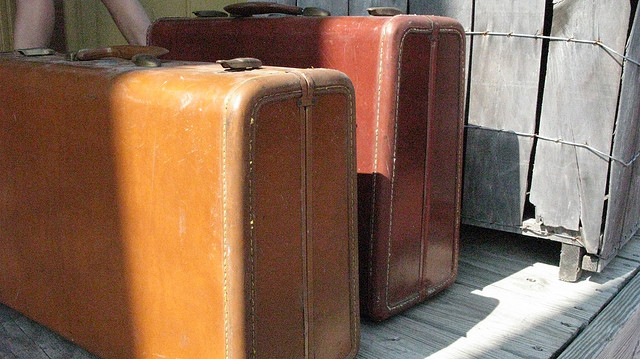<image>What is peeling off of the suitcase? It is ambiguous what is peeling off of the suitcase. It could be paint, stickers, or leather. What is peeling off of the suitcase? It is ambiguous what is peeling off of the suitcase. It can be either paint, stickers, or leather. 